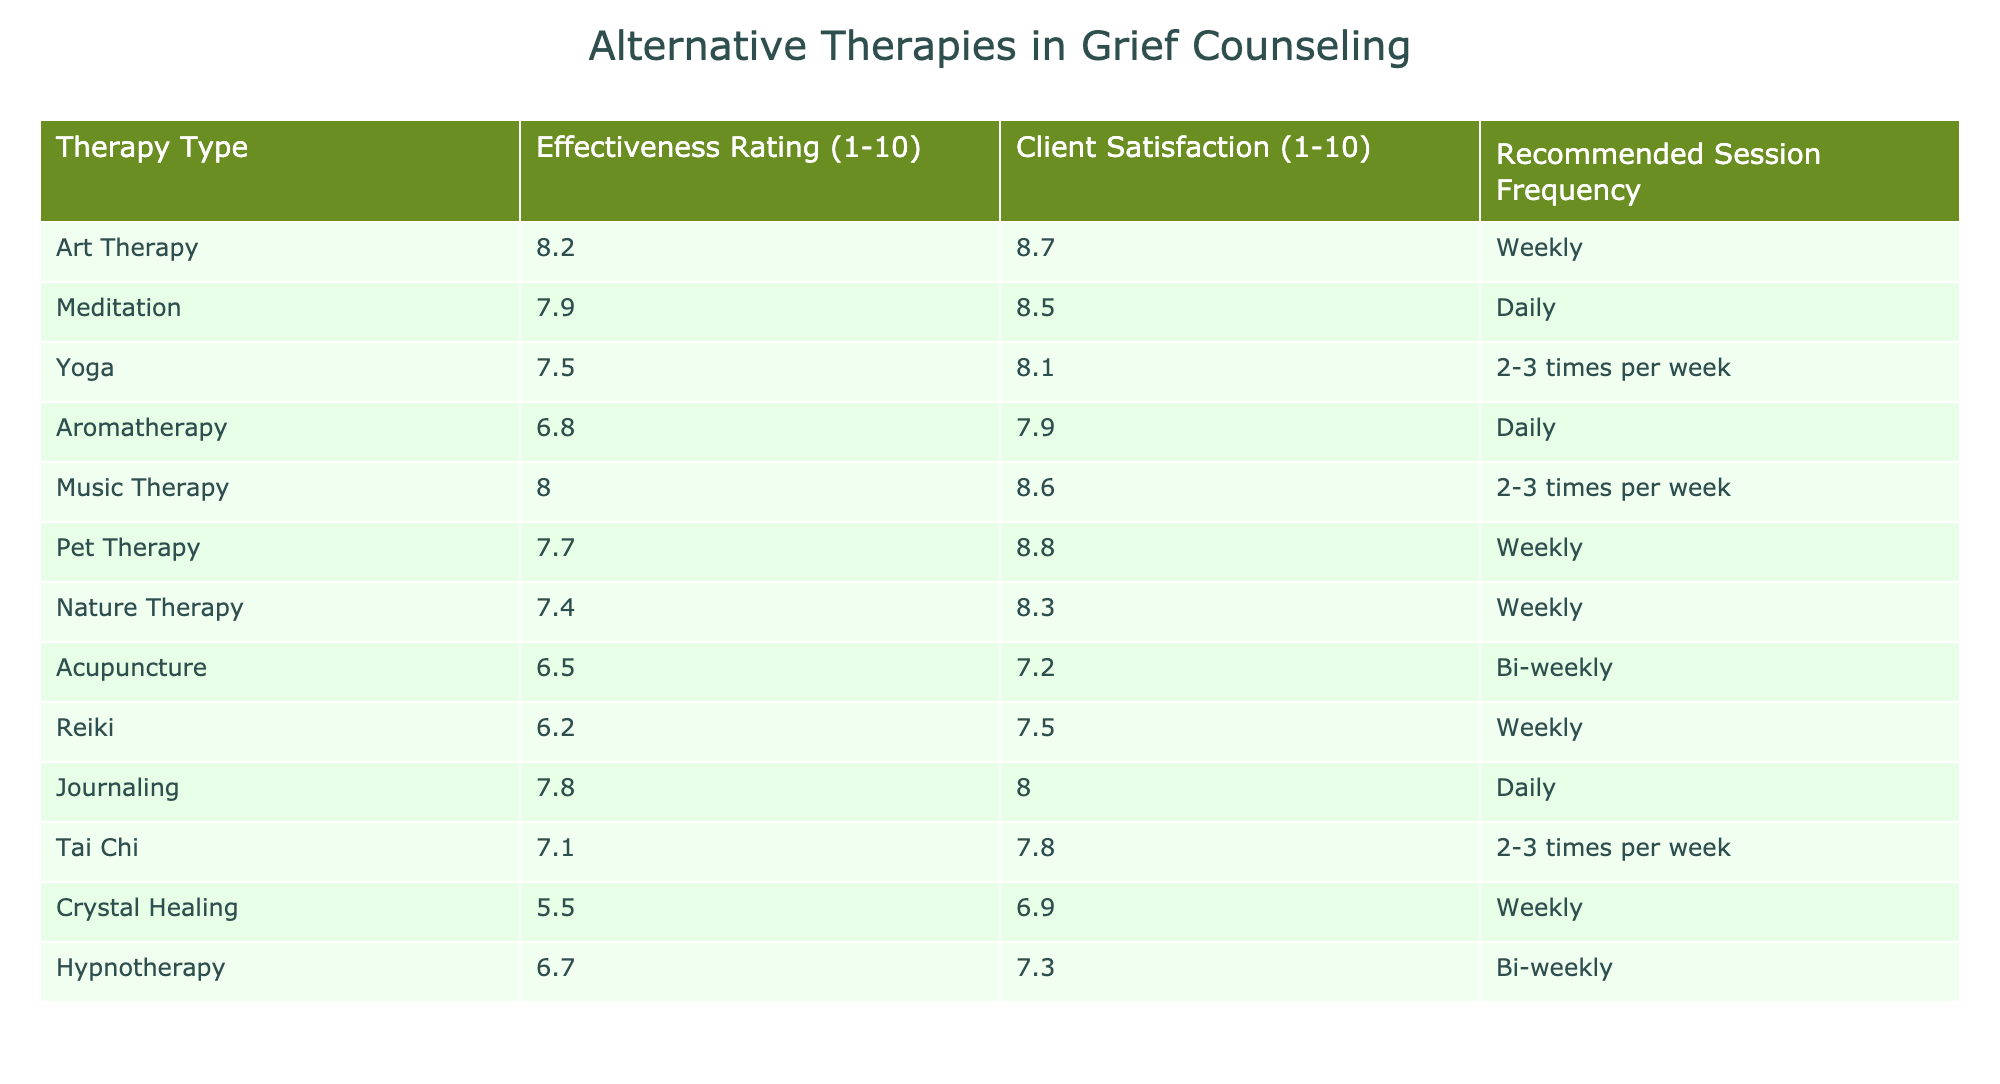What is the effectiveness rating of Art Therapy? The table directly lists the effectiveness rating of Art Therapy in the corresponding column, which is 8.2.
Answer: 8.2 Which therapy has the highest client satisfaction rating? By examining the Client Satisfaction column, we can see that Pet Therapy has the highest rating at 8.8.
Answer: Pet Therapy What is the average effectiveness rating of the therapies listed? To find the average effectiveness rating, sum all the effectiveness ratings (8.2 + 7.9 + 7.5 + 6.8 + 8.0 + 7.7 + 7.4 + 6.5 + 6.2 + 7.8 + 7.1 + 5.5 + 6.7 = 87.4) and divide by the number of therapies (13), which gives us an average of 87.4 / 13 ≈ 6.73.
Answer: 6.73 Is Aromatherapy less effective than Tai Chi? Aromatherapy has an effectiveness rating of 6.8, while Tai Chi has a rating of 7.1. Since 6.8 is less than 7.1, the statement is true.
Answer: Yes Which therapies have a recommended session frequency of 'Weekly'? You need to check the Recommended Session Frequency column for therapies listed as 'Weekly'. They are Art Therapy, Pet Therapy, Nature Therapy, and Reiki.
Answer: Art Therapy, Pet Therapy, Nature Therapy, Reiki What is the difference between the effectiveness ratings of Music Therapy and Hypnotherapy? The effectiveness rating for Music Therapy is 8.0, while for Hypnotherapy it is 6.7. The difference can be calculated as 8.0 - 6.7 = 1.3.
Answer: 1.3 Are any therapies recommended for daily sessions? Checking the Recommended Session Frequency column, Aromatherapy and Journaling are both recommended for daily sessions. Therefore, there are indeed therapies recommended for daily sessions.
Answer: Yes Which therapy has a lower client satisfaction rating than its effectiveness rating? By comparing both ratings, Crystal Healing (Client Satisfaction 6.9, Effectiveness 5.5) and Reiki (Client Satisfaction 7.5, Effectiveness 6.2) have lower client satisfaction ratings than effectiveness ratings, but only Crystal Healing meets this condition.
Answer: Crystal Healing What is the recommended session frequency for the therapy with the highest effectiveness rating? First, identify the highest effectiveness rating, which belongs to Art Therapy at 8.2. The recommended session frequency for Art Therapy is 'Weekly'.
Answer: Weekly 